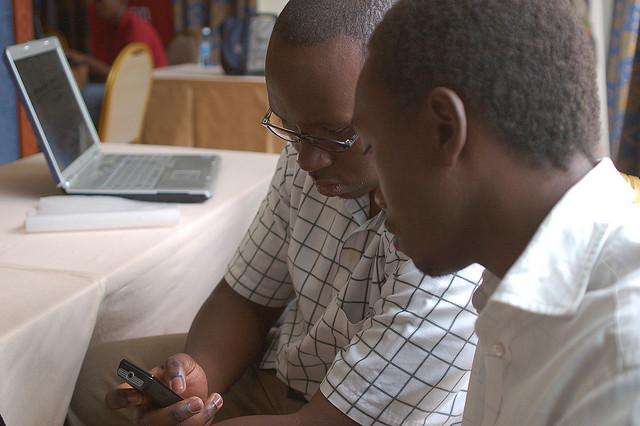Is anyone wearing a watch?
Concise answer only. No. What are they playing with?
Give a very brief answer. Phone. What pattern is the man's shirt?
Short answer required. Checkered. Are both of their shirts buttoned up?
Short answer required. Yes. What is the boy holding?
Give a very brief answer. Phone. Where was this photo taken?
Keep it brief. School. Is the laptop in use?
Write a very short answer. No. What are the two men doing?
Short answer required. Texting. What race is the large man on the right?
Short answer required. Black. Are they both wearing glasses?
Concise answer only. No. Is that a flip phone in the picture?
Write a very short answer. No. What is on the table?
Keep it brief. Laptop. What are they looking at?
Concise answer only. Phone. What is the hairstyle called?
Short answer required. Short. What function is this?
Short answer required. Phone. Does he have a beard?
Be succinct. No. Is this a kitchen?
Concise answer only. No. What are the people doing here?
Concise answer only. Looking at phone. How many buttons are on the phone?
Concise answer only. 15. What color is the phone?
Give a very brief answer. Black. How many phones do they have?
Keep it brief. 1. 